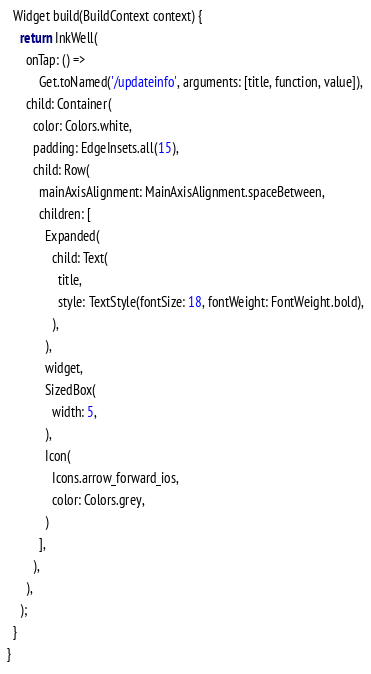<code> <loc_0><loc_0><loc_500><loc_500><_Dart_>  Widget build(BuildContext context) {
    return InkWell(
      onTap: () =>
          Get.toNamed('/updateinfo', arguments: [title, function, value]),
      child: Container(
        color: Colors.white,
        padding: EdgeInsets.all(15),
        child: Row(
          mainAxisAlignment: MainAxisAlignment.spaceBetween,
          children: [
            Expanded(
              child: Text(
                title,
                style: TextStyle(fontSize: 18, fontWeight: FontWeight.bold),
              ),
            ),
            widget,
            SizedBox(
              width: 5,
            ),
            Icon(
              Icons.arrow_forward_ios,
              color: Colors.grey,
            )
          ],
        ),
      ),
    );
  }
}
</code> 